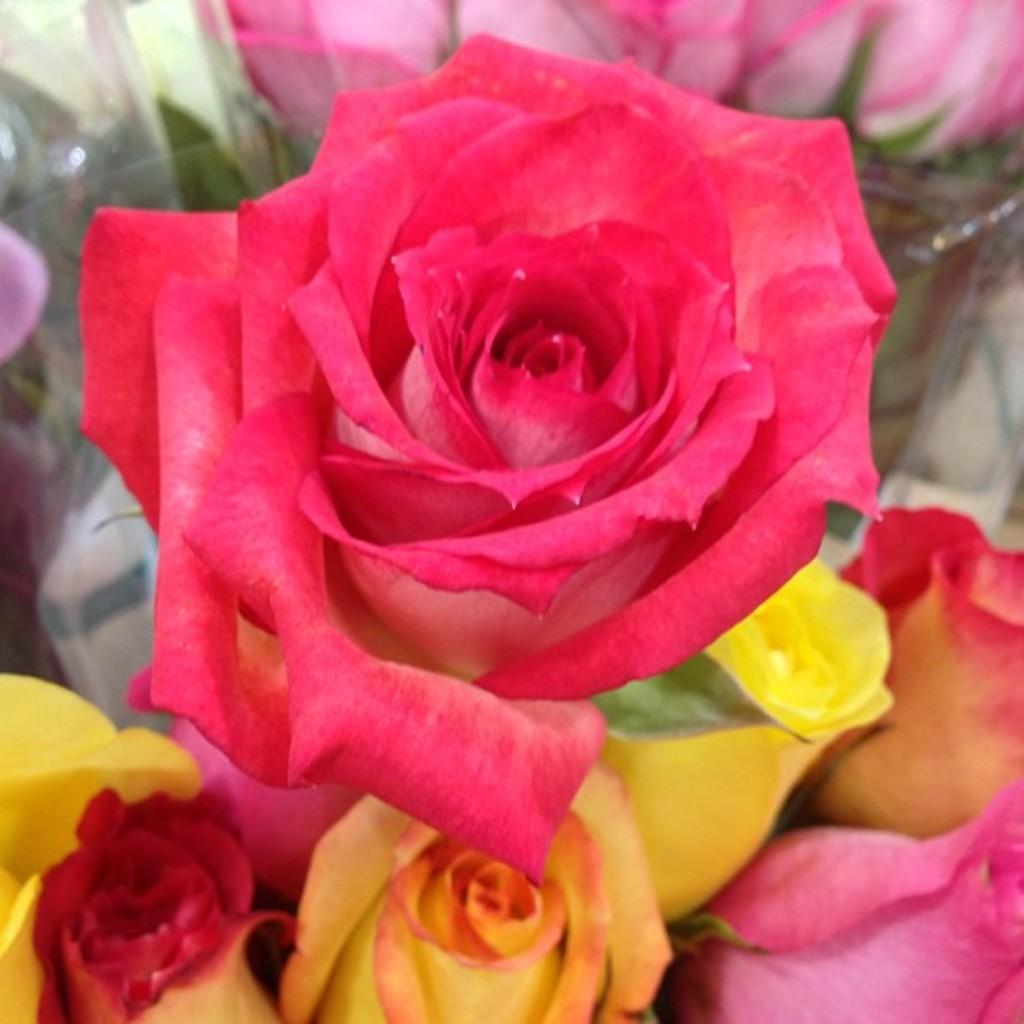What type of plants are in the image? There are colorful flowers in the image. What is covering the flowers in the image? There is a cover in the image. Reasoning: Let's think step by identifying the main subjects and objects in the image based on the provided facts. We then formulate questions that focus on the location and characteristics of these subjects and objects, ensuring that each question can be answered definitively with the information given. We avoid yes/no questions and ensure that the language is simple and clear. Absurd Question/Answer: What type of debt is associated with the flowers in the image? There is no mention of debt in the image, as it features colorful flowers and a cover. What surprise can be seen in the middle of the image? There is no surprise present in the image; it only contains colorful flowers and a cover. 